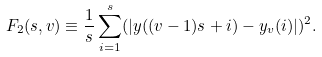<formula> <loc_0><loc_0><loc_500><loc_500>F _ { 2 } ( s , v ) \equiv \frac { 1 } { s } \sum _ { i = 1 } ^ { s } ( | y ( ( v - 1 ) s + i ) - y _ { v } ( i ) | ) ^ { 2 } .</formula> 